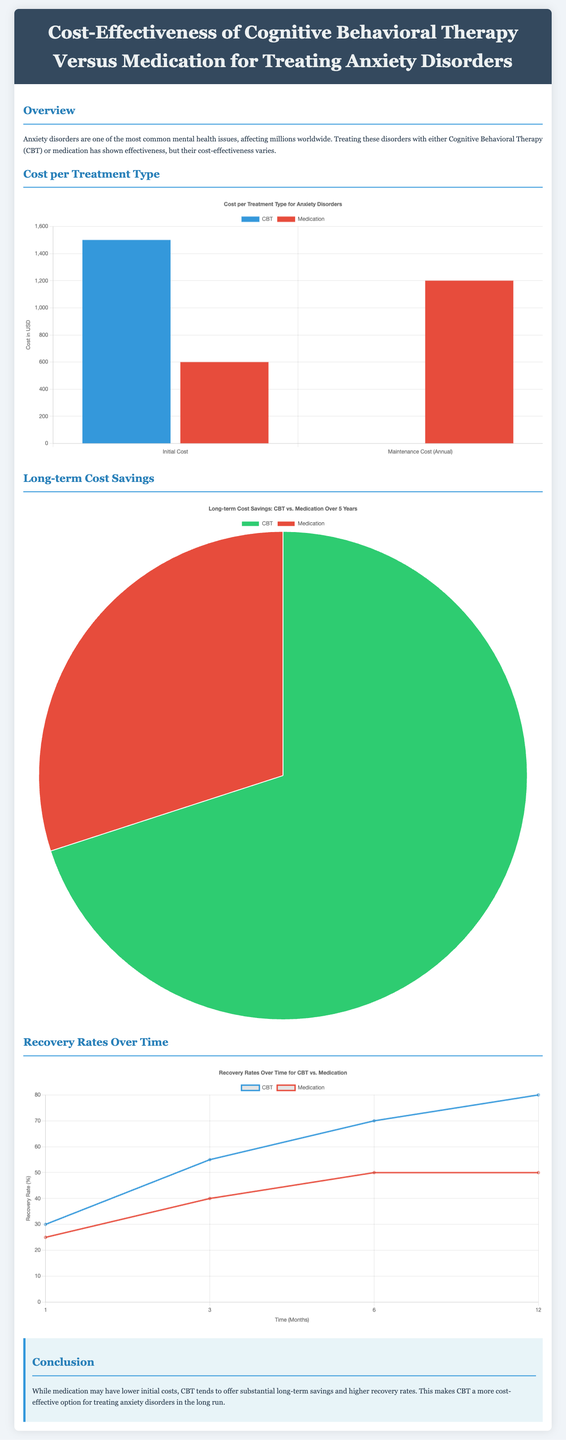What are the initial costs of CBT and medication? The initial cost of CBT is $1500, while the initial cost of medication is $600.
Answer: $1500 and $600 What is the annual maintenance cost for medication? The document indicates the maintenance cost for medication is $1200 annually.
Answer: $1200 How much of the long-term cost savings is attributed to CBT? The pie chart shows that 70% of the long-term cost savings are attributed to CBT.
Answer: 70% What is the recovery rate for CBT at 12 months? The line chart indicates that the recovery rate for CBT at 12 months is 80%.
Answer: 80% At 6 months, what is the recovery rate for medication? According to the chart, the recovery rate for medication at 6 months is 50%.
Answer: 50% Which treatment shows higher recovery rates over time? The recovery rates chart suggests that CBT shows higher recovery rates compared to medication over time.
Answer: CBT What is the purpose of the infographic? The infographic aims to compare the cost-effectiveness of CBT versus medication for treating anxiety disorders.
Answer: Compare cost-effectiveness What color represents CBT in the cost per treatment type chart? In the cost chart, CBT is represented by the color blue.
Answer: Blue What time period is displayed in the recovery rates over time chart? The recovery rates over time chart displays data for 1, 3, 6, and 12 months.
Answer: 1, 3, 6, and 12 months 